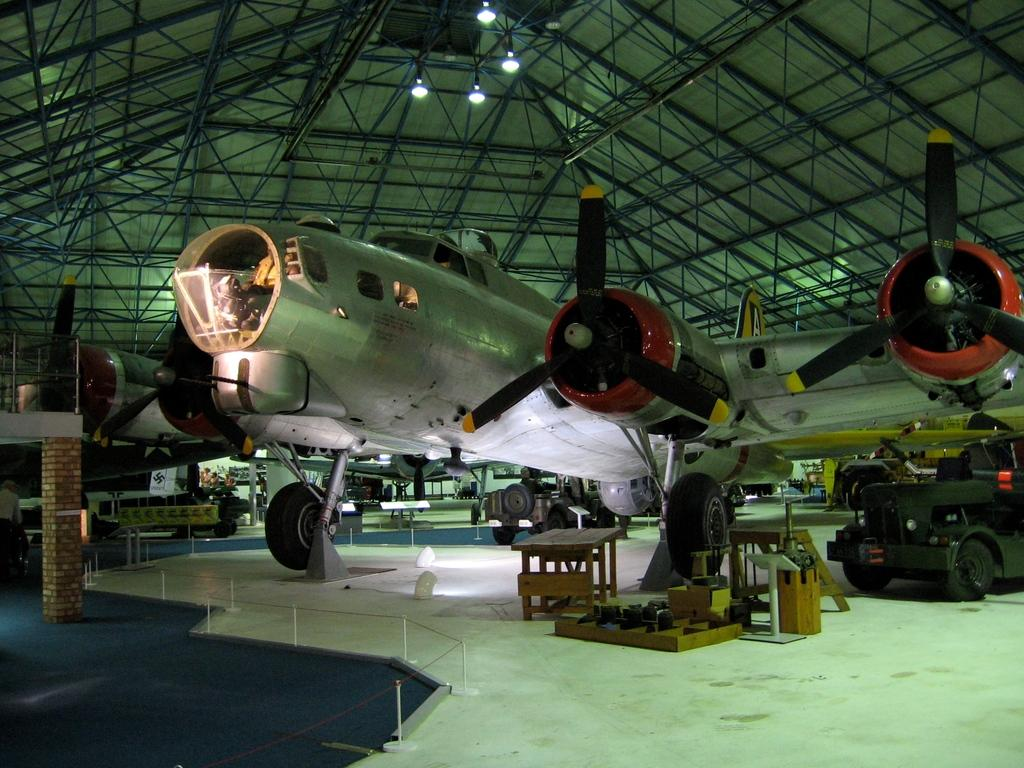What is the main subject of the image? The main subject of the image is an aircraft. Are there any other vehicles or objects in the image? Yes, there is a vehicle in the image. What type of loaf is the farmer holding while feeding the duck in the image? There is no loaf, farmer, or duck present in the image. 